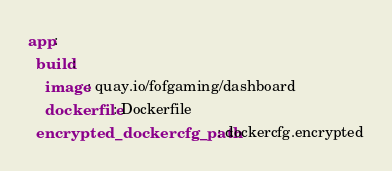Convert code to text. <code><loc_0><loc_0><loc_500><loc_500><_YAML_>app:
  build:
    image: quay.io/fofgaming/dashboard
    dockerfile: Dockerfile
  encrypted_dockercfg_path: dockercfg.encrypted</code> 